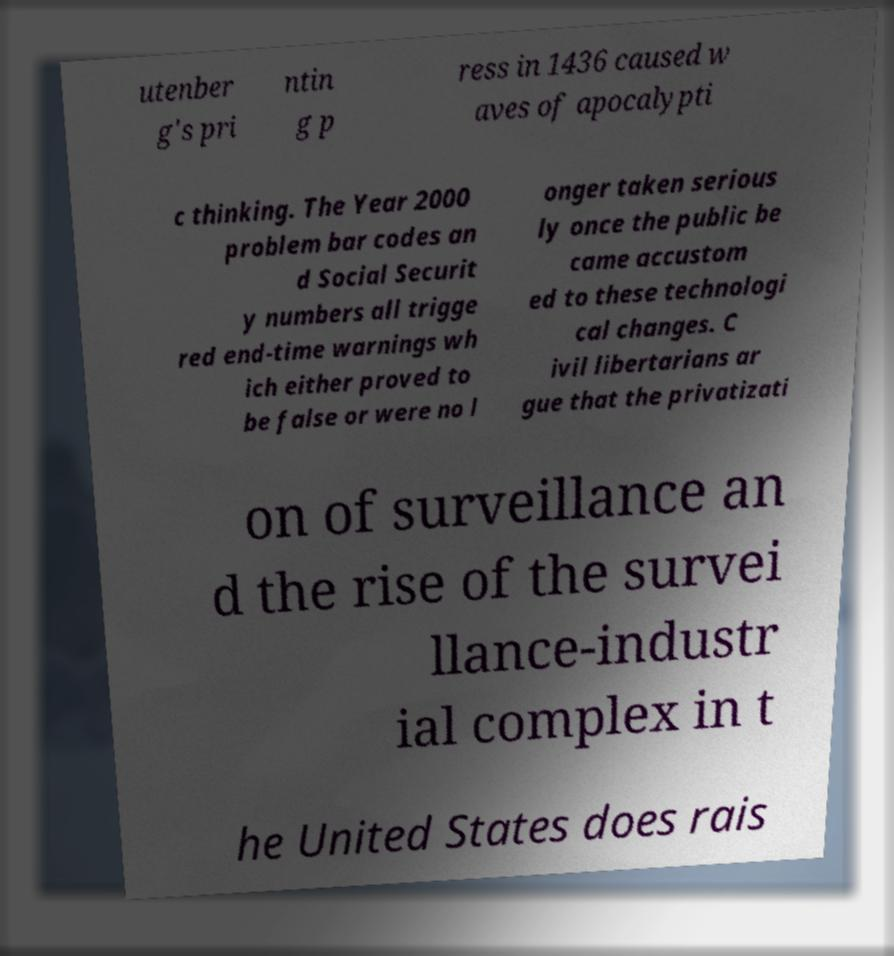What messages or text are displayed in this image? I need them in a readable, typed format. utenber g's pri ntin g p ress in 1436 caused w aves of apocalypti c thinking. The Year 2000 problem bar codes an d Social Securit y numbers all trigge red end-time warnings wh ich either proved to be false or were no l onger taken serious ly once the public be came accustom ed to these technologi cal changes. C ivil libertarians ar gue that the privatizati on of surveillance an d the rise of the survei llance-industr ial complex in t he United States does rais 